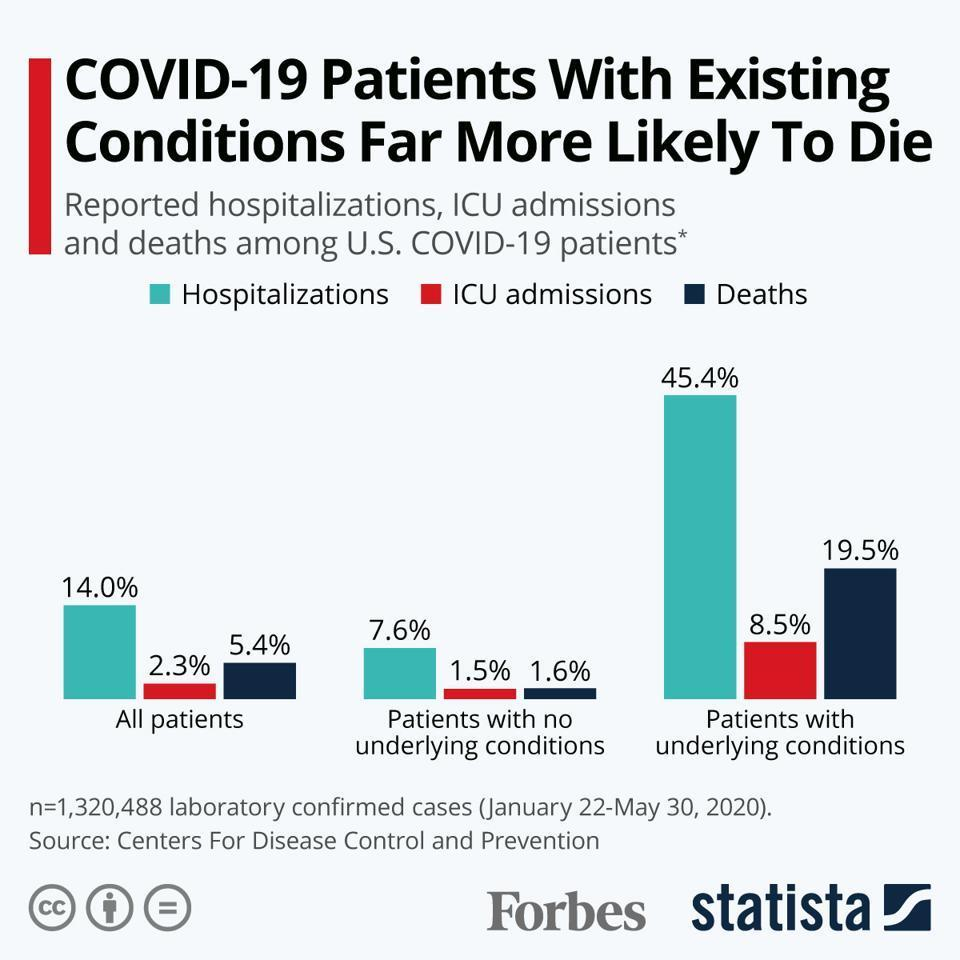What percentage of Covid-19 patients in the U.S  with underlying conditions were hospitalised?
Answer the question with a short phrase. 45.4% What percentage of Covid-19 patients in the U.S with no underlying conditions were hospitalised? 7.6% What percentage of Covid-19 patients   in the U.S. with no underlying conditions were admitted to ICU? 1.5% What percentage of Covid-19 patients  with no underlying conditions succumbed to death in the U.S.? 1.6% What percentage of Covid-19 patients in the U.S. with underlying conditions succumbed to death? 19.5% 